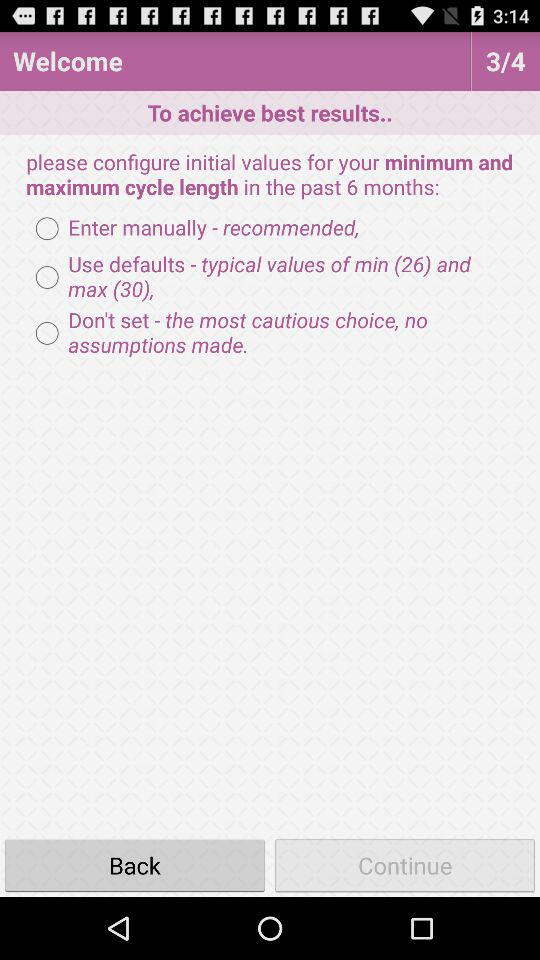How many pages in total are there? There are 4 pages. 